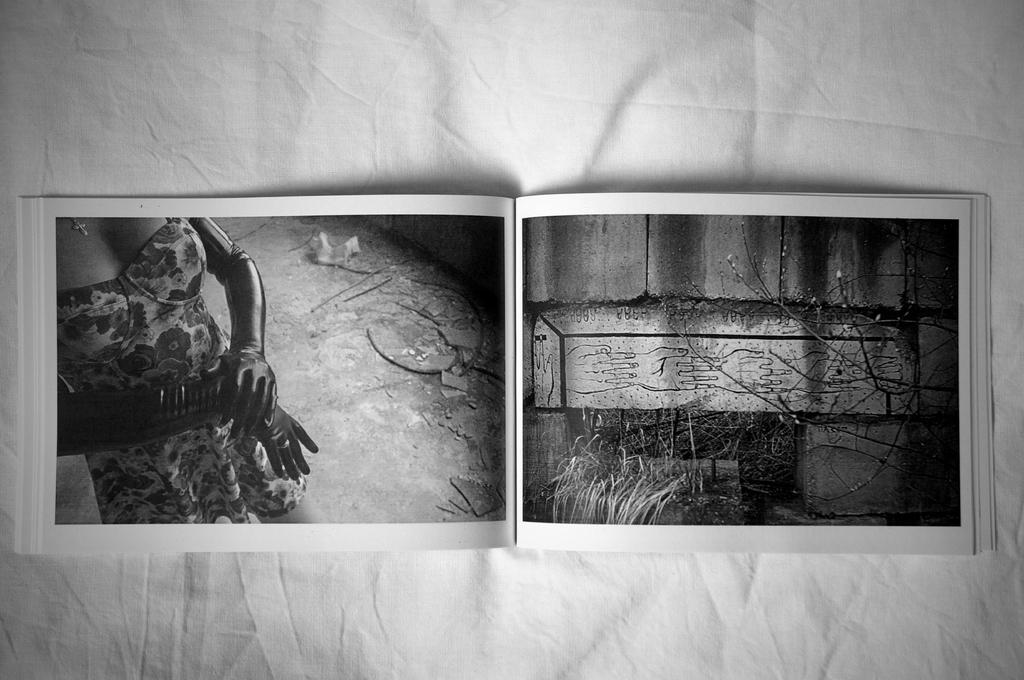What is the main subject in the middle of the image? There is a book in the middle of the image. What can be seen on the pages of the book? The book has images on two pages. What is the book placed on? The book is placed on a cloth. What is the color of the background in the image? The background of the image is white in color. What type of zinc object is present in the image? There is no zinc object present in the image. How does the arm of the person holding the book look like in the image? There is no person holding the book in the image, so it is not possible to describe the arm. 